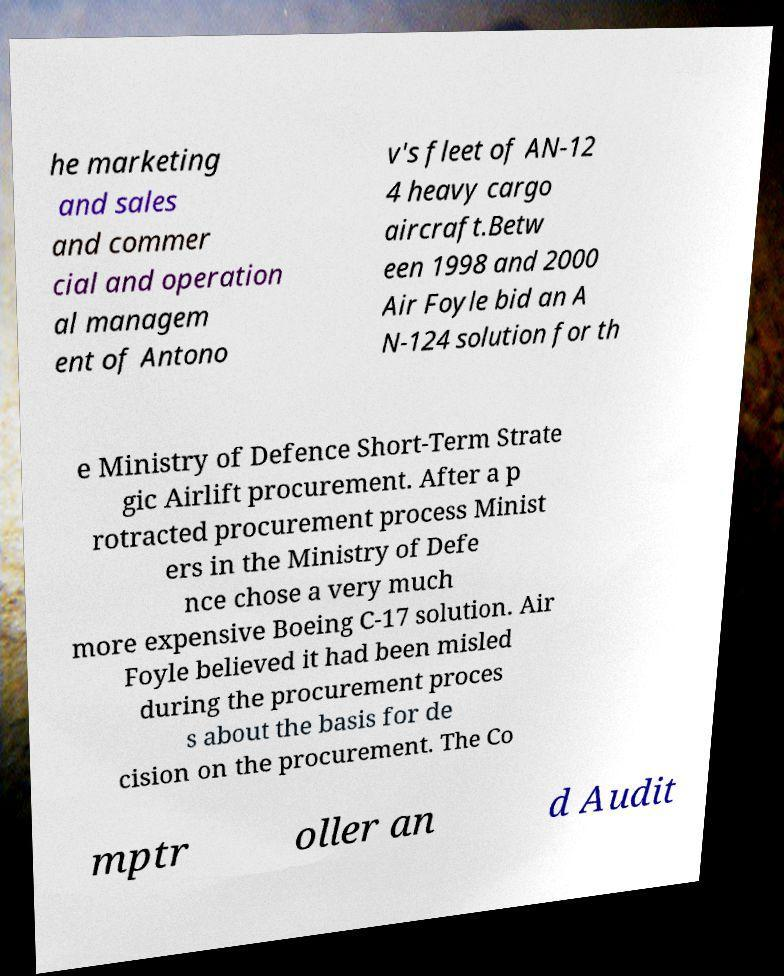I need the written content from this picture converted into text. Can you do that? he marketing and sales and commer cial and operation al managem ent of Antono v's fleet of AN-12 4 heavy cargo aircraft.Betw een 1998 and 2000 Air Foyle bid an A N-124 solution for th e Ministry of Defence Short-Term Strate gic Airlift procurement. After a p rotracted procurement process Minist ers in the Ministry of Defe nce chose a very much more expensive Boeing C-17 solution. Air Foyle believed it had been misled during the procurement proces s about the basis for de cision on the procurement. The Co mptr oller an d Audit 